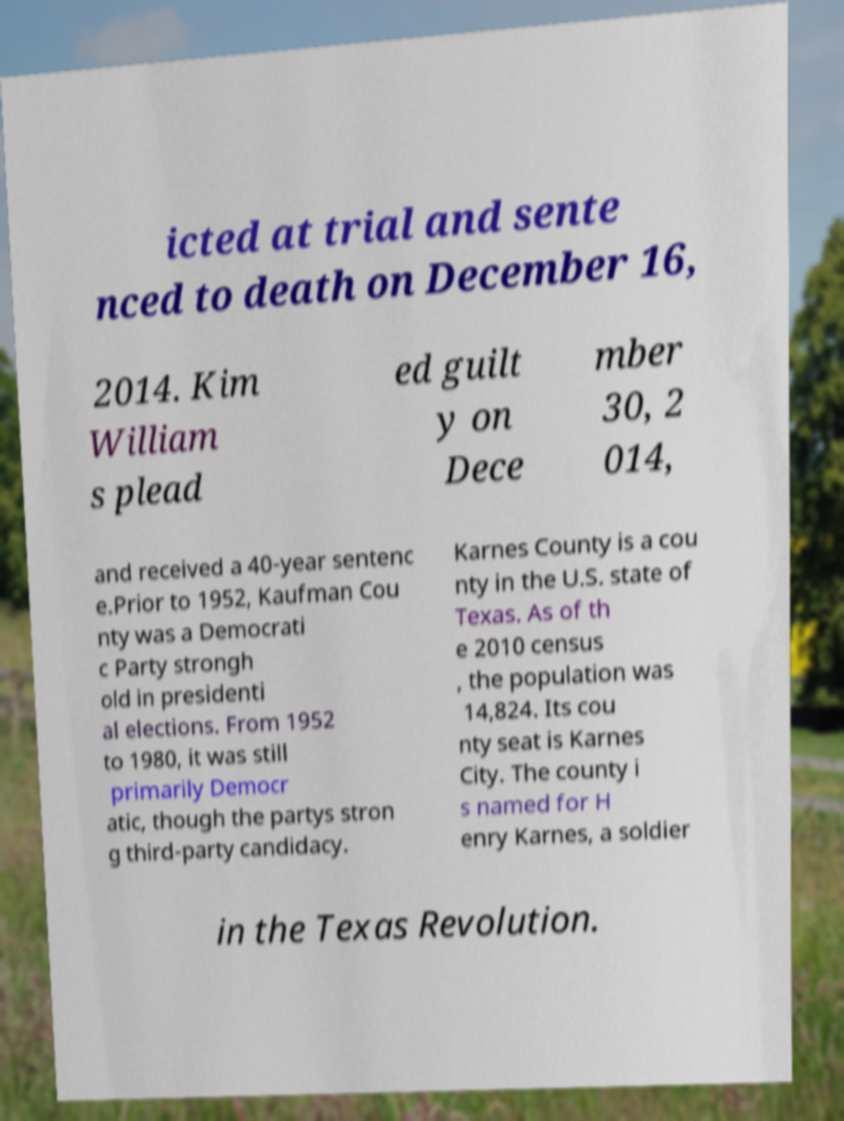Could you assist in decoding the text presented in this image and type it out clearly? icted at trial and sente nced to death on December 16, 2014. Kim William s plead ed guilt y on Dece mber 30, 2 014, and received a 40-year sentenc e.Prior to 1952, Kaufman Cou nty was a Democrati c Party strongh old in presidenti al elections. From 1952 to 1980, it was still primarily Democr atic, though the partys stron g third-party candidacy. Karnes County is a cou nty in the U.S. state of Texas. As of th e 2010 census , the population was 14,824. Its cou nty seat is Karnes City. The county i s named for H enry Karnes, a soldier in the Texas Revolution. 